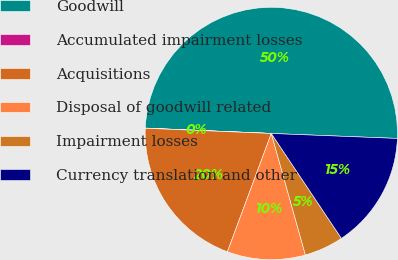<chart> <loc_0><loc_0><loc_500><loc_500><pie_chart><fcel>Goodwill<fcel>Accumulated impairment losses<fcel>Acquisitions<fcel>Disposal of goodwill related<fcel>Impairment losses<fcel>Currency translation and other<nl><fcel>49.95%<fcel>0.02%<fcel>20.0%<fcel>10.01%<fcel>5.02%<fcel>15.0%<nl></chart> 